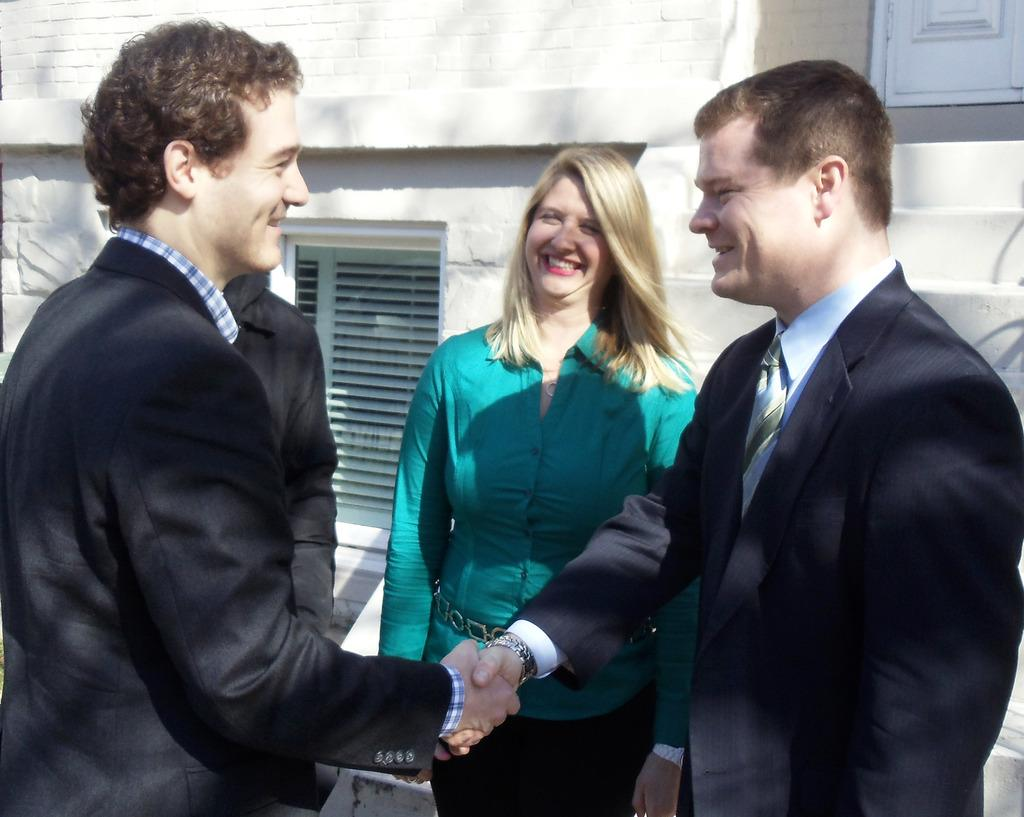How many people are in the image? There is a group of people in the image. What are two men in the image doing? Two men in the image are shaking hands. What can be seen behind the people in the image? There is a wall visible in the image. What architectural features are present in the image? There are windows and stairs in the image. What type of paste is being used by the people in the image? There is no mention of paste in the image. 